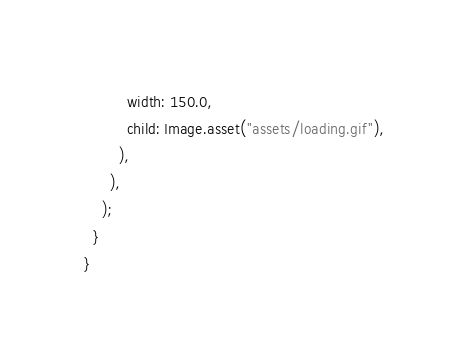Convert code to text. <code><loc_0><loc_0><loc_500><loc_500><_Dart_>          width: 150.0,
          child: Image.asset("assets/loading.gif"),
        ),
      ),
    );
  }
}
</code> 